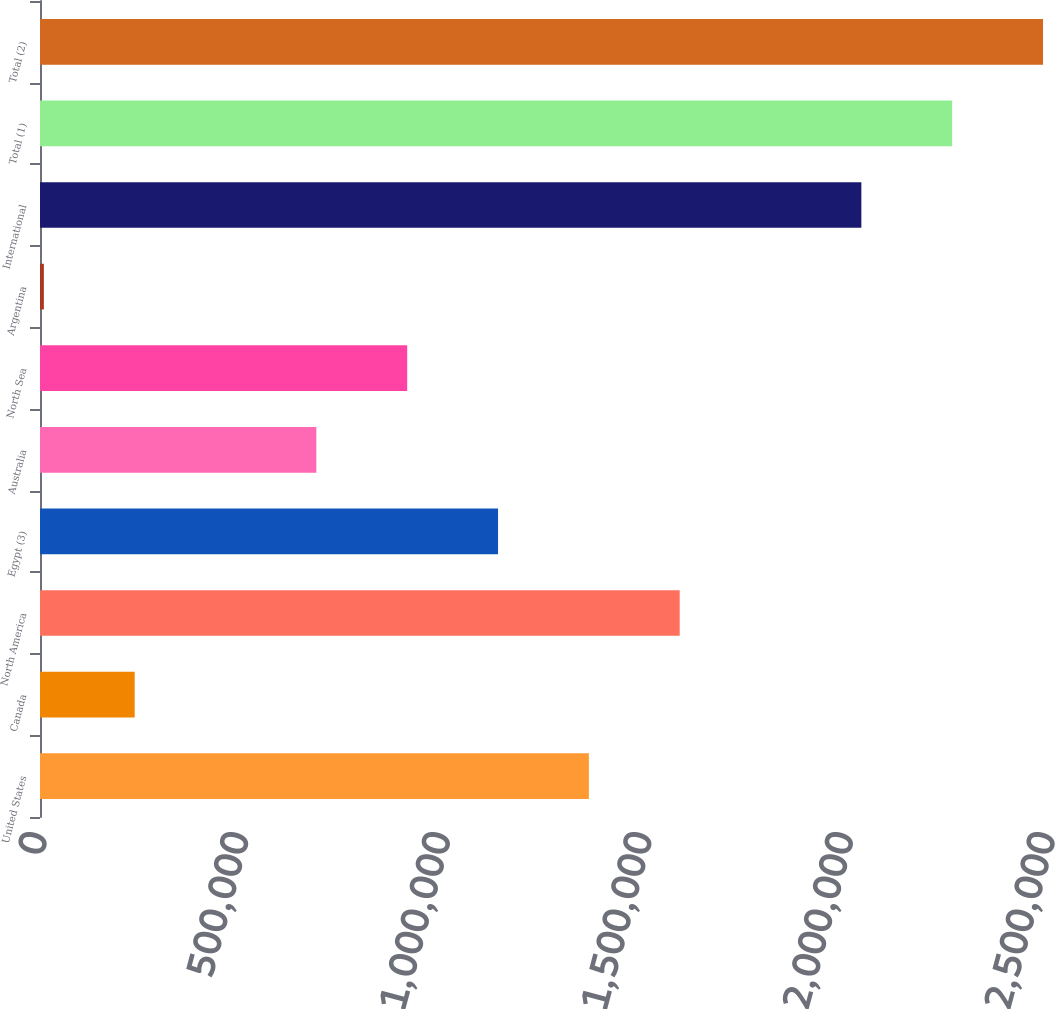Convert chart to OTSL. <chart><loc_0><loc_0><loc_500><loc_500><bar_chart><fcel>United States<fcel>Canada<fcel>North America<fcel>Egypt (3)<fcel>Australia<fcel>North Sea<fcel>Argentina<fcel>International<fcel>Total (1)<fcel>Total (2)<nl><fcel>1.36127e+06<fcel>234876<fcel>1.58655e+06<fcel>1.13599e+06<fcel>685433<fcel>910712<fcel>9597<fcel>2.03711e+06<fcel>2.26238e+06<fcel>2.48766e+06<nl></chart> 